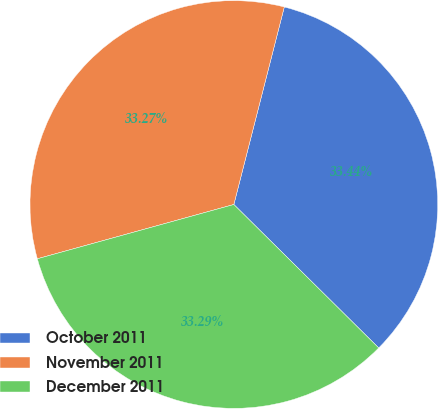<chart> <loc_0><loc_0><loc_500><loc_500><pie_chart><fcel>October 2011<fcel>November 2011<fcel>December 2011<nl><fcel>33.44%<fcel>33.27%<fcel>33.29%<nl></chart> 